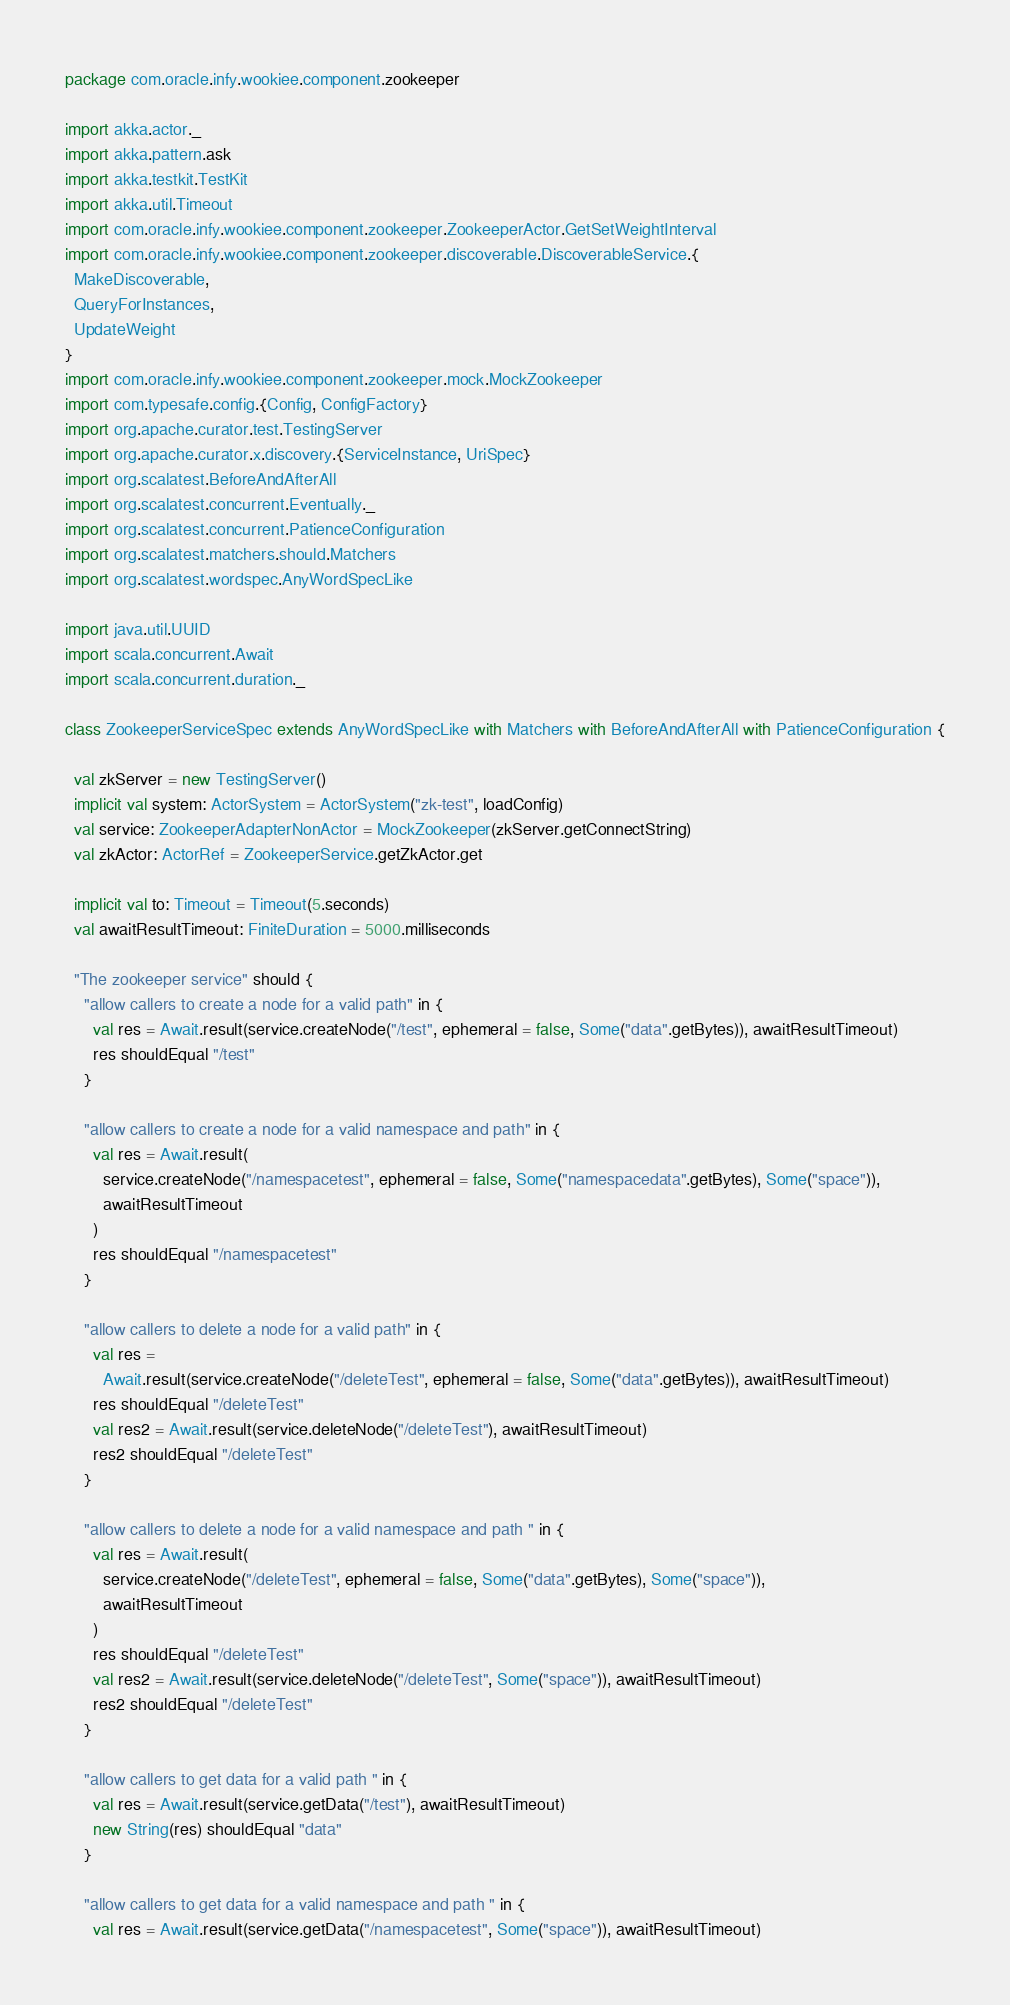Convert code to text. <code><loc_0><loc_0><loc_500><loc_500><_Scala_>package com.oracle.infy.wookiee.component.zookeeper

import akka.actor._
import akka.pattern.ask
import akka.testkit.TestKit
import akka.util.Timeout
import com.oracle.infy.wookiee.component.zookeeper.ZookeeperActor.GetSetWeightInterval
import com.oracle.infy.wookiee.component.zookeeper.discoverable.DiscoverableService.{
  MakeDiscoverable,
  QueryForInstances,
  UpdateWeight
}
import com.oracle.infy.wookiee.component.zookeeper.mock.MockZookeeper
import com.typesafe.config.{Config, ConfigFactory}
import org.apache.curator.test.TestingServer
import org.apache.curator.x.discovery.{ServiceInstance, UriSpec}
import org.scalatest.BeforeAndAfterAll
import org.scalatest.concurrent.Eventually._
import org.scalatest.concurrent.PatienceConfiguration
import org.scalatest.matchers.should.Matchers
import org.scalatest.wordspec.AnyWordSpecLike

import java.util.UUID
import scala.concurrent.Await
import scala.concurrent.duration._

class ZookeeperServiceSpec extends AnyWordSpecLike with Matchers with BeforeAndAfterAll with PatienceConfiguration {

  val zkServer = new TestingServer()
  implicit val system: ActorSystem = ActorSystem("zk-test", loadConfig)
  val service: ZookeeperAdapterNonActor = MockZookeeper(zkServer.getConnectString)
  val zkActor: ActorRef = ZookeeperService.getZkActor.get

  implicit val to: Timeout = Timeout(5.seconds)
  val awaitResultTimeout: FiniteDuration = 5000.milliseconds

  "The zookeeper service" should {
    "allow callers to create a node for a valid path" in {
      val res = Await.result(service.createNode("/test", ephemeral = false, Some("data".getBytes)), awaitResultTimeout)
      res shouldEqual "/test"
    }

    "allow callers to create a node for a valid namespace and path" in {
      val res = Await.result(
        service.createNode("/namespacetest", ephemeral = false, Some("namespacedata".getBytes), Some("space")),
        awaitResultTimeout
      )
      res shouldEqual "/namespacetest"
    }

    "allow callers to delete a node for a valid path" in {
      val res =
        Await.result(service.createNode("/deleteTest", ephemeral = false, Some("data".getBytes)), awaitResultTimeout)
      res shouldEqual "/deleteTest"
      val res2 = Await.result(service.deleteNode("/deleteTest"), awaitResultTimeout)
      res2 shouldEqual "/deleteTest"
    }

    "allow callers to delete a node for a valid namespace and path " in {
      val res = Await.result(
        service.createNode("/deleteTest", ephemeral = false, Some("data".getBytes), Some("space")),
        awaitResultTimeout
      )
      res shouldEqual "/deleteTest"
      val res2 = Await.result(service.deleteNode("/deleteTest", Some("space")), awaitResultTimeout)
      res2 shouldEqual "/deleteTest"
    }

    "allow callers to get data for a valid path " in {
      val res = Await.result(service.getData("/test"), awaitResultTimeout)
      new String(res) shouldEqual "data"
    }

    "allow callers to get data for a valid namespace and path " in {
      val res = Await.result(service.getData("/namespacetest", Some("space")), awaitResultTimeout)</code> 